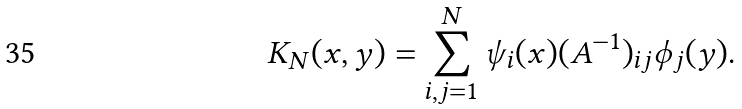<formula> <loc_0><loc_0><loc_500><loc_500>K _ { N } ( x , y ) = \sum _ { i , j = 1 } ^ { N } \psi _ { i } ( x ) ( A ^ { - 1 } ) _ { i j } \phi _ { j } ( y ) .</formula> 